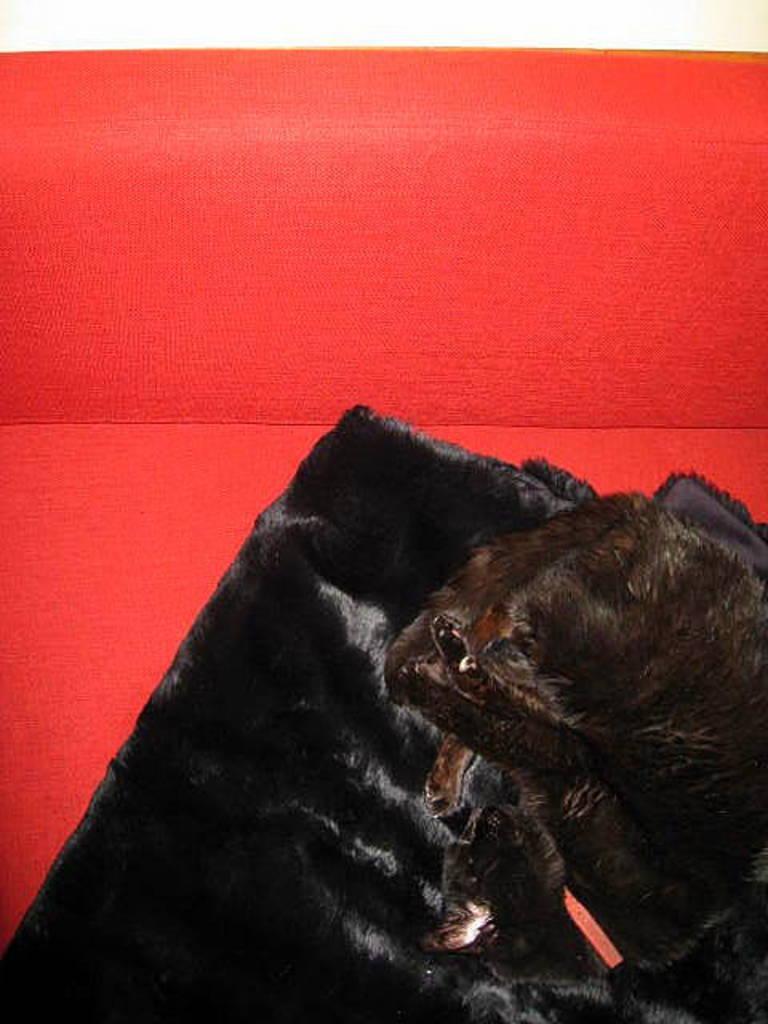Please provide a concise description of this image. This image consists of a cat sleeping on a blanket. It is in black color. In the background, there is a sofa in red color. The cat is also in black color. 